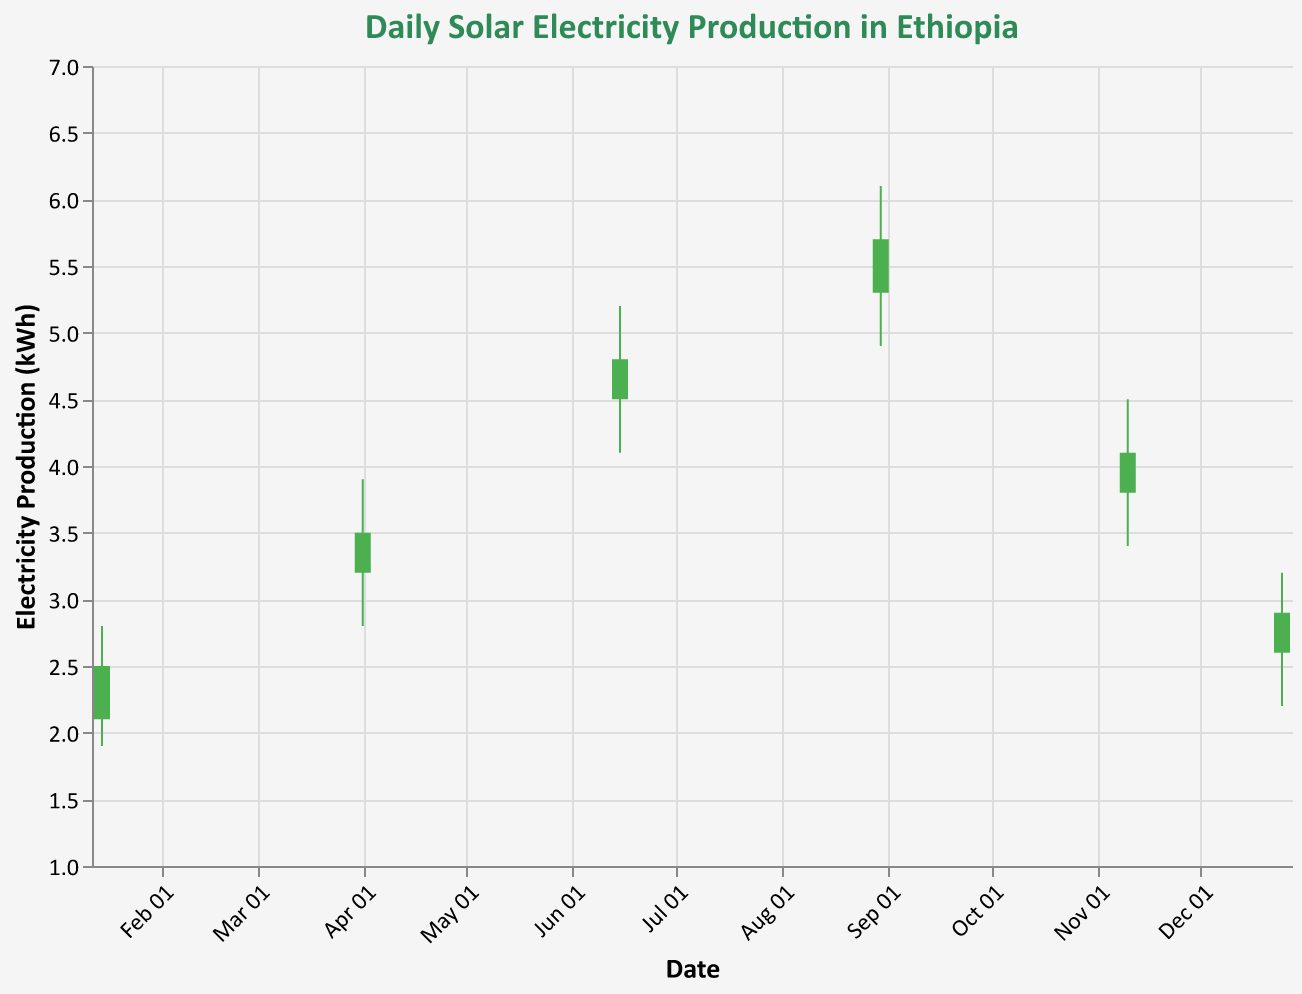What's the highest electricity production recorded in the year shown in the chart? The highest production is marked by the "High" value on the largest candlestick, which is 6.1 kWh on August 30, 2023.
Answer: 6.1 kWh How many data points are represented in the chart? By counting the dates, we see there are 6 data points: January 15, April 1, June 15, August 30, November 10, and December 25.
Answer: 6 During which month was the electricity production at its lowest point? The lowest production is marked by the "Low" value, which is 1.9 kWh on January 15.
Answer: January How does the electricity production on June 15 compare to April 1? The production on June 15 (4.1-5.2 kWh) is higher than on April 1 (2.8-3.9 kWh) considering both high and low values.
Answer: June 15 > April 1 Which month shows an overall decrease in electricity production? The electricity production decreased in December, marked by the Open (2.6 kWh) being higher than the Close (2.9 kWh) value.
Answer: December What's the range of electricity production on November 10? The range is calculated by subtracting the Low value from the High value on November 10, which is 4.5 - 3.4 = 1.1 kWh.
Answer: 1.1 kWh Which data point shows the largest increase in production from open to close? Comparing Open and Close values across all dates, August 30 shows the largest increase from 5.3 kWh to 5.7 kWh, which is an increase of 0.4 kWh.
Answer: August 30 What's the average "High" electricity production recorded across all data points? Sum of all High values: 2.8 + 3.9 + 5.2 + 6.1 + 4.5 + 3.2 = 25.7 kWh, divided by 6 data points = 25.7 / 6 ≈ 4.28 kWh.
Answer: 4.28 kWh Which date shows the smallest difference between the high and low values? By examining the differences: 
January 15: 2.8 - 1.9 = 0.9,
April 1: 3.9 - 2.8 = 1.1,
June 15: 5.2 - 4.1 = 1.1,
August 30: 6.1 - 4.9 = 1.2,
November 10: 4.5 - 3.4 = 1.1,
December 25: 3.2 - 2.2 = 1.
December 25 shows the smallest difference of 1 kWh.
Answer: December 25 